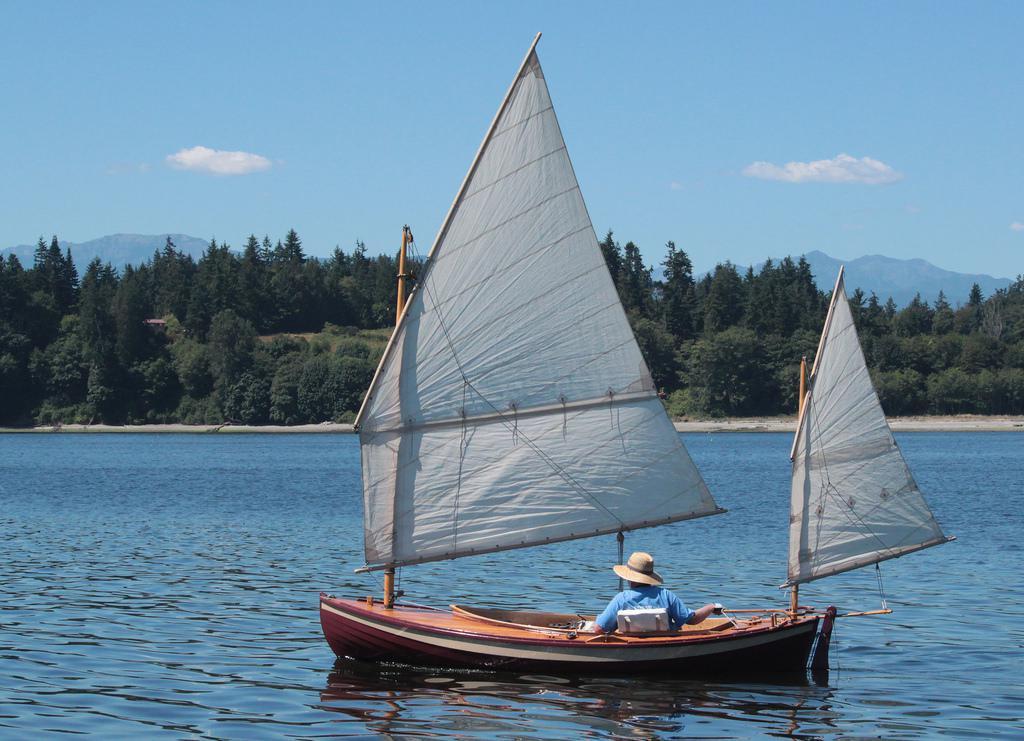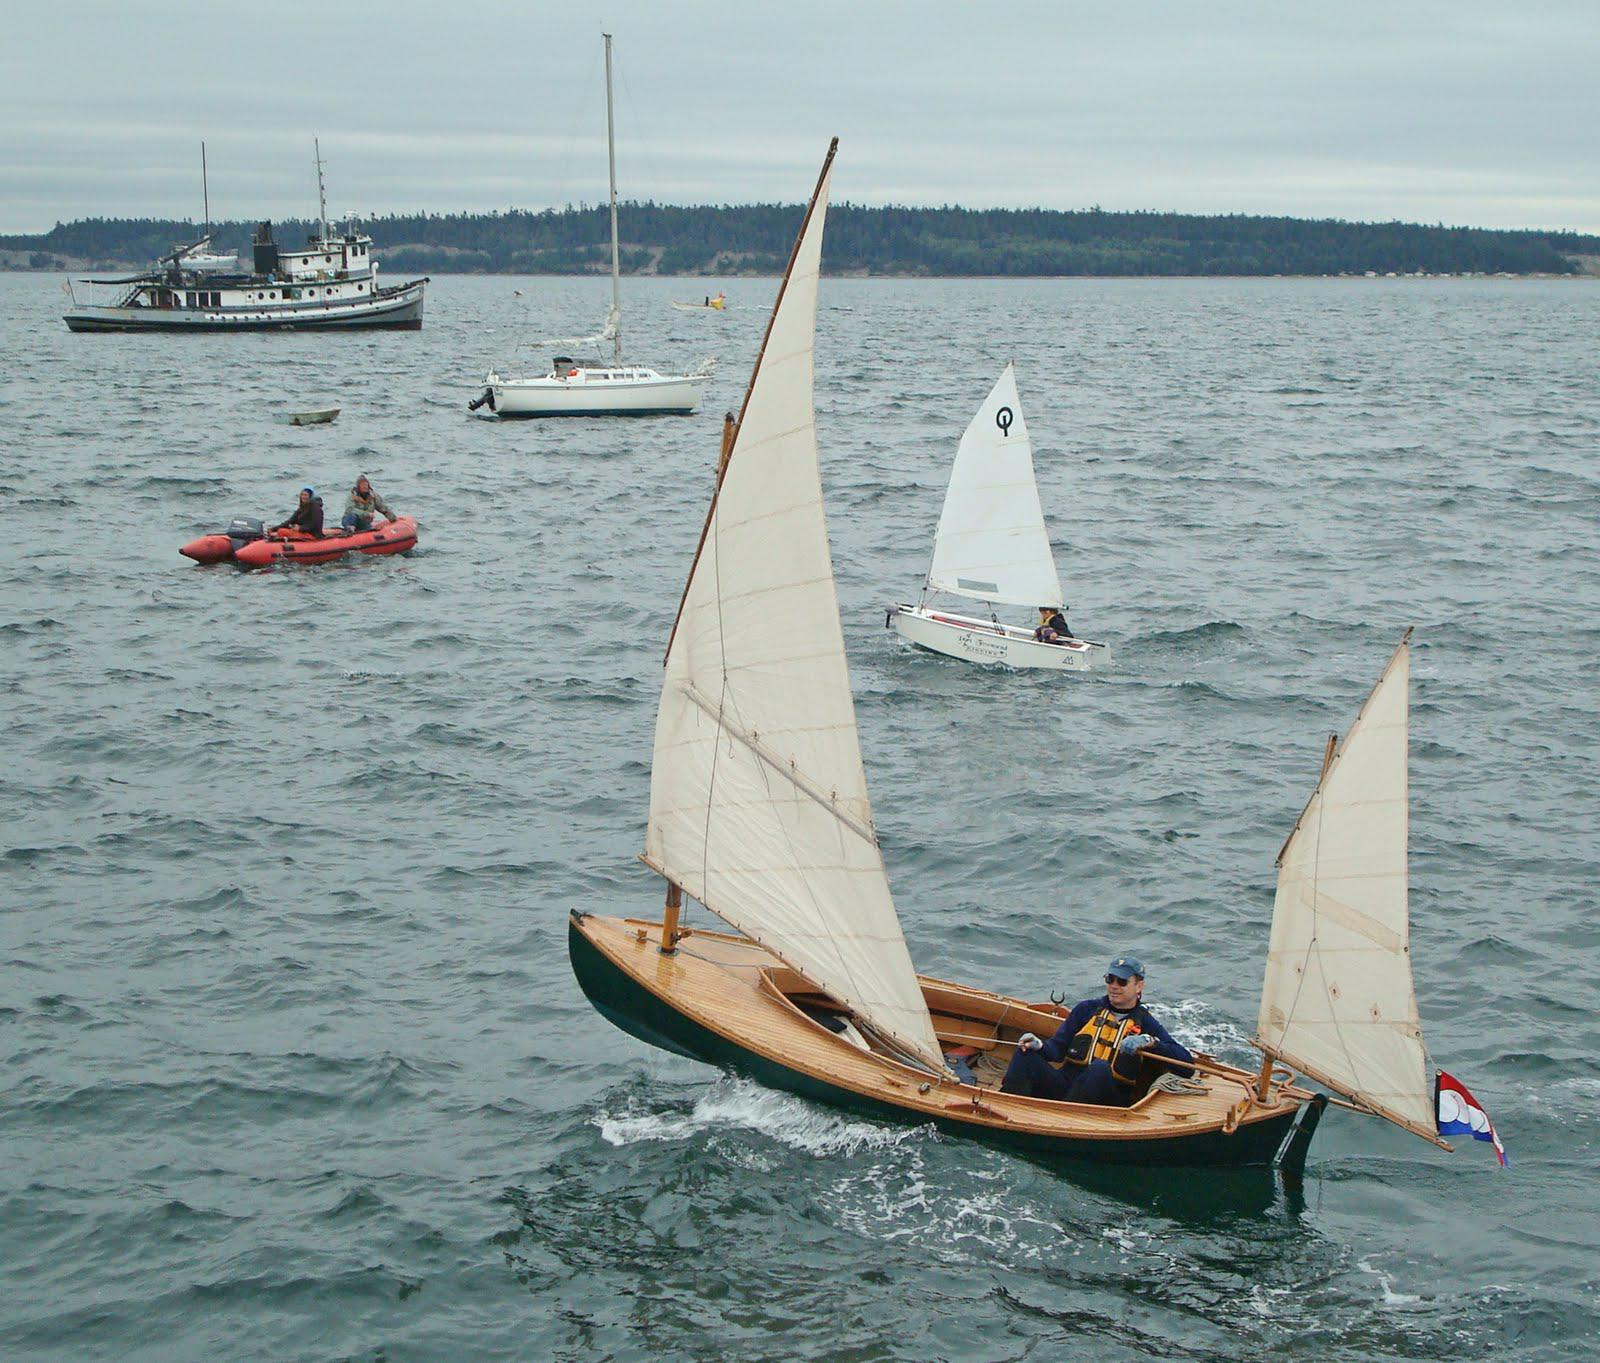The first image is the image on the left, the second image is the image on the right. Evaluate the accuracy of this statement regarding the images: "All the sails are white.". Is it true? Answer yes or no. Yes. The first image is the image on the left, the second image is the image on the right. Evaluate the accuracy of this statement regarding the images: "In the left image there is a person in a boat wearing a hate with two raised sails". Is it true? Answer yes or no. Yes. 